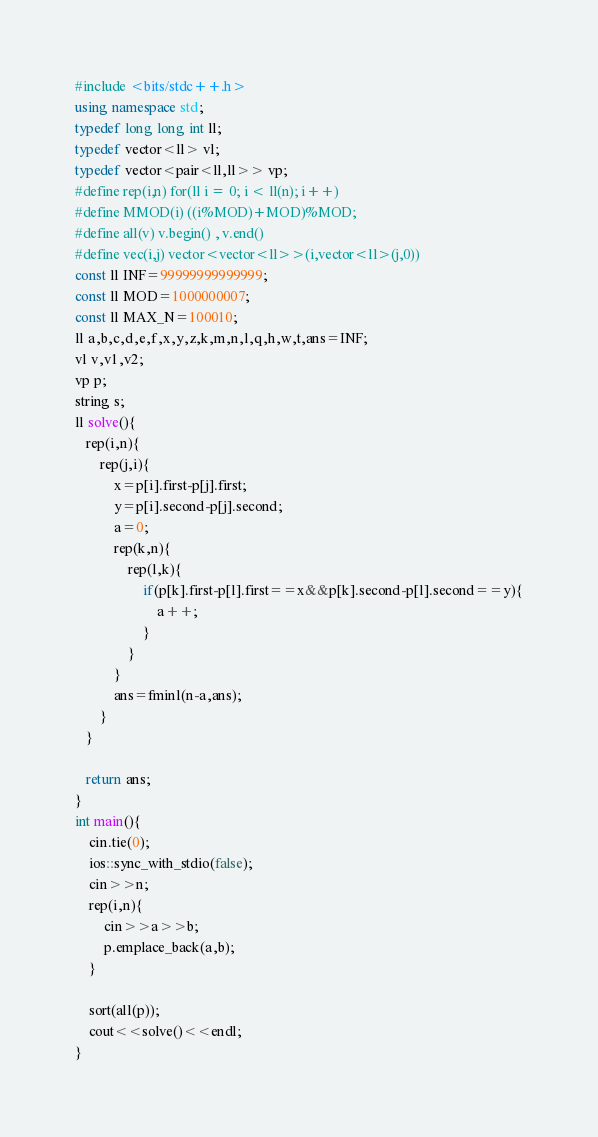<code> <loc_0><loc_0><loc_500><loc_500><_C++_>#include <bits/stdc++.h>
using namespace std;
typedef long long int ll;
typedef vector<ll> vl;
typedef vector<pair<ll,ll>> vp;
#define rep(i,n) for(ll i = 0; i < ll(n); i++)
#define MMOD(i) ((i%MOD)+MOD)%MOD;
#define all(v) v.begin() , v.end()
#define vec(i,j) vector<vector<ll>>(i,vector<ll>(j,0))
const ll INF=99999999999999;
const ll MOD=1000000007;
const ll MAX_N=100010;
ll a,b,c,d,e,f,x,y,z,k,m,n,l,q,h,w,t,ans=INF;
vl v,v1,v2;
vp p;
string s;
ll solve(){
   rep(i,n){
       rep(j,i){
           x=p[i].first-p[j].first;
           y=p[i].second-p[j].second;
           a=0;
           rep(k,n){
               rep(l,k){
                   if(p[k].first-p[l].first==x&&p[k].second-p[l].second==y){
                       a++;
                   }
               }
           }
           ans=fminl(n-a,ans);
       }
   }
 
   return ans;
}
int main(){
    cin.tie(0);
    ios::sync_with_stdio(false);
    cin>>n;
    rep(i,n){
        cin>>a>>b;
        p.emplace_back(a,b);
    }
 
    sort(all(p));
    cout<<solve()<<endl;
}</code> 